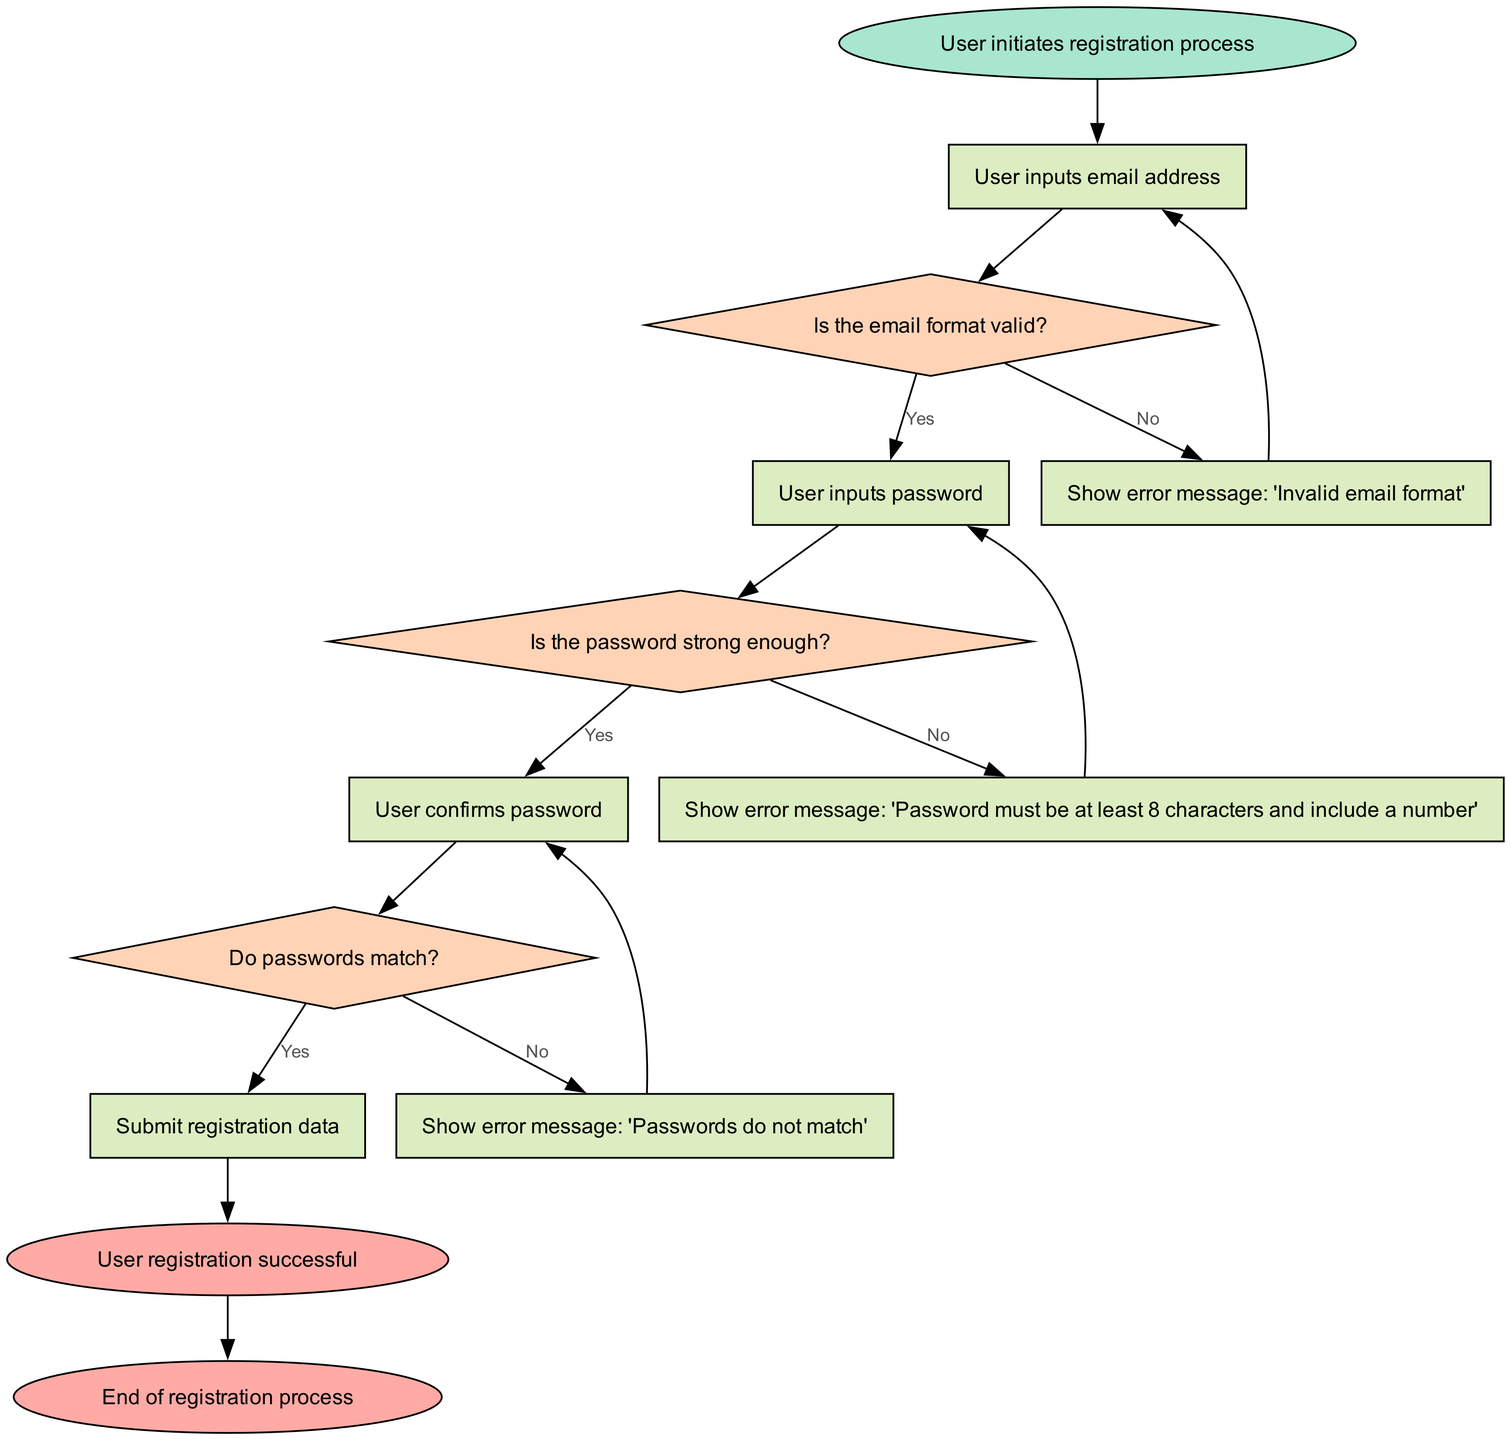What is the starting point of the registration process? The diagram begins with the node labeled "User initiates registration process". This node represents the starting point of the entire registration flow.
Answer: User initiates registration process What message is shown if the email format is invalid? When the decision point checking the email format leads to "No", the process directs to the node "Show error message: 'Invalid email format'", indicating that this message will be displayed in case the format is incorrect.
Answer: Show error message: 'Invalid email format' How many total decision nodes are present? The diagram contains three decision nodes: "Is the email format valid?", "Is the password strong enough?", and "Do passwords match?". By counting these nodes, we can determine the total as three.
Answer: 3 What happens if the passwords do not match? If the passwords do not match, the flow directs to the node "Show error message: 'Passwords do not match'", indicating that an error message will be displayed, guiding the user to correct the input.
Answer: Show error message: 'Passwords do not match' What is the final output of the registration process? The last node in the flow is labeled "User registration successful", which signifies that this is the endpoint and the outcome when the registration process completes successfully.
Answer: User registration successful What occurs after submitting registration data? Following the node "Submit registration data", the process moves to the node "User registration successful", which indicates that the submission results in a successful user registration.
Answer: User registration successful What message is displayed if the password is too weak? If the validation of the password fails and it is deemed weak, the flow leads to "Show error message: 'Password must be at least 8 characters and include a number'", which communicates the specific issues with the user's password choice.
Answer: Show error message: 'Password must be at least 8 characters and include a number' Which node follows the "EnterPassword" node? The flow proceeds from "EnterPassword" to the decision node "ValidatePassword", as this is the next logical step where the password's strength is evaluated after entry.
Answer: ValidatePassword How many total nodes are there in the diagram? By counting all the process, decision, start, and end nodes within the diagram, there are fifteen nodes in total included in the user registration flow.
Answer: 15 